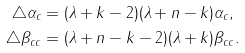<formula> <loc_0><loc_0><loc_500><loc_500>\triangle \alpha _ { c } & = ( \lambda + k - 2 ) ( \lambda + n - k ) \alpha _ { c } , \\ \triangle \beta _ { c c } & = ( \lambda + n - k - 2 ) ( \lambda + k ) \beta _ { c c } .</formula> 